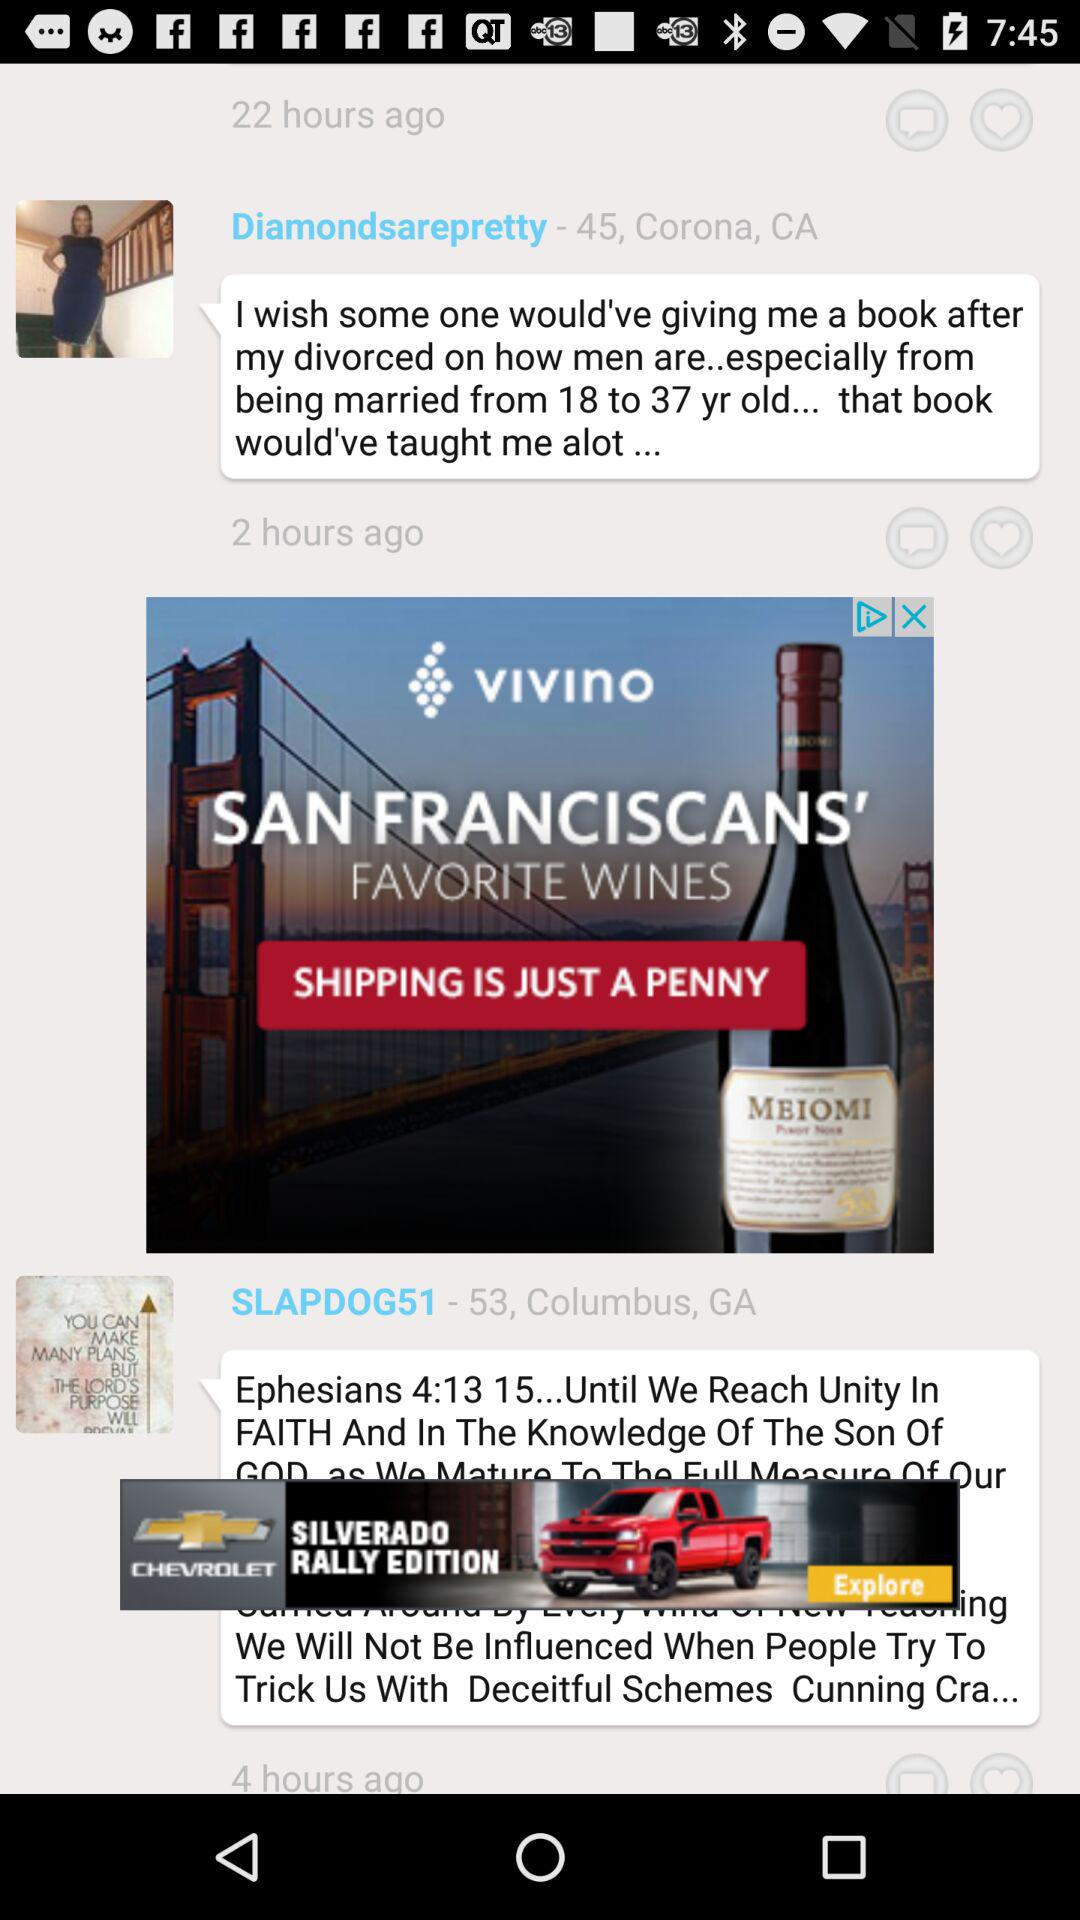What is the age of "Diamondsarepretty"? The age is 45 years. 